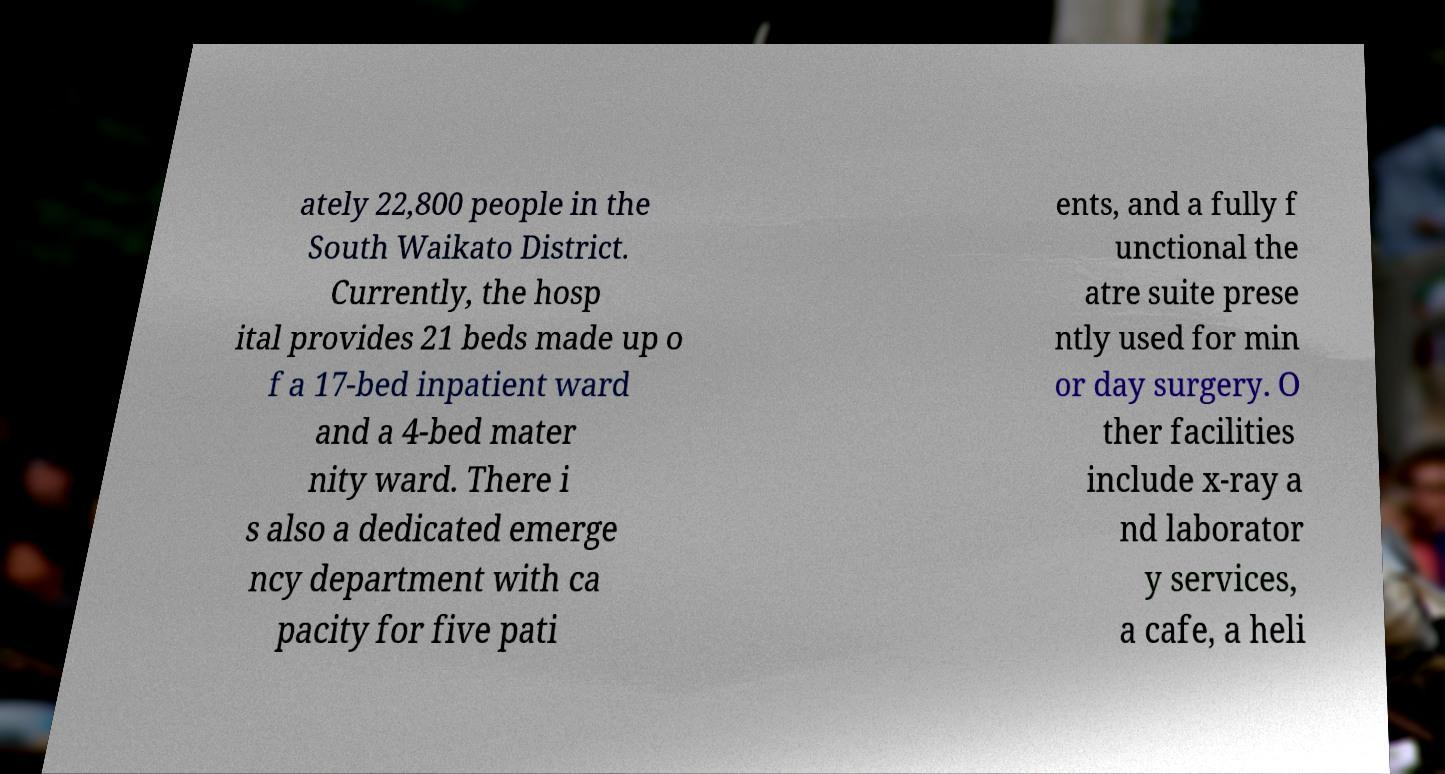What messages or text are displayed in this image? I need them in a readable, typed format. ately 22,800 people in the South Waikato District. Currently, the hosp ital provides 21 beds made up o f a 17-bed inpatient ward and a 4-bed mater nity ward. There i s also a dedicated emerge ncy department with ca pacity for five pati ents, and a fully f unctional the atre suite prese ntly used for min or day surgery. O ther facilities include x-ray a nd laborator y services, a cafe, a heli 